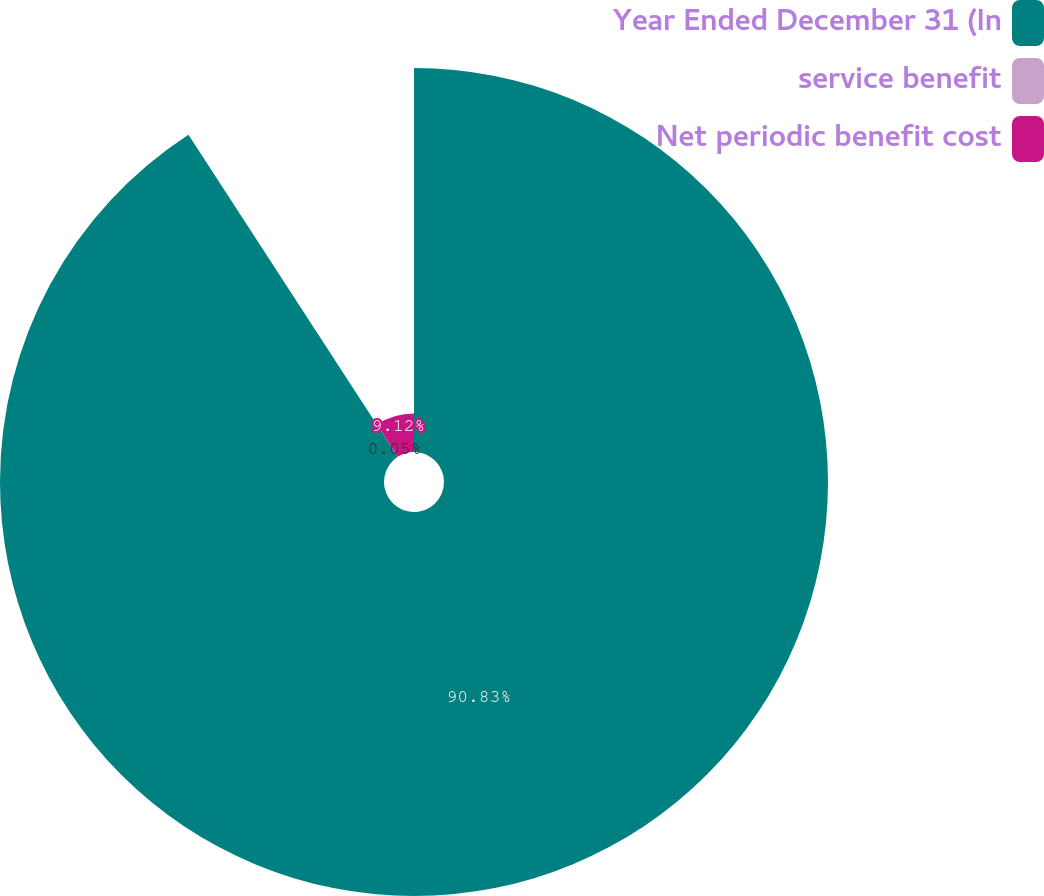Convert chart. <chart><loc_0><loc_0><loc_500><loc_500><pie_chart><fcel>Year Ended December 31 (In<fcel>service benefit<fcel>Net periodic benefit cost<nl><fcel>90.83%<fcel>0.05%<fcel>9.12%<nl></chart> 